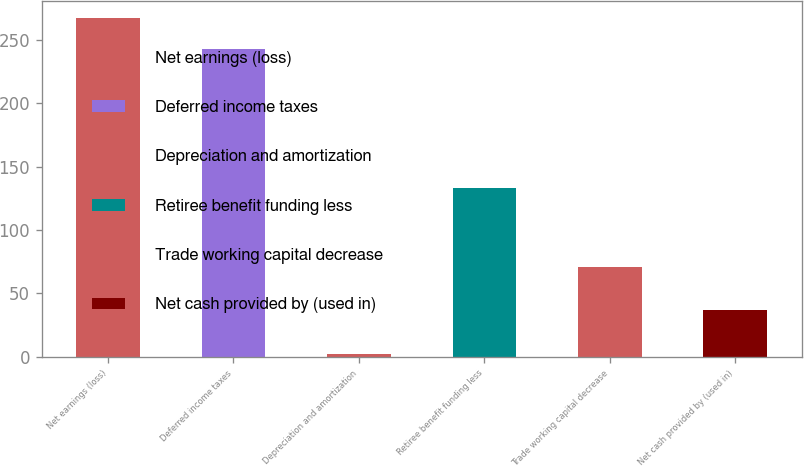Convert chart to OTSL. <chart><loc_0><loc_0><loc_500><loc_500><bar_chart><fcel>Net earnings (loss)<fcel>Deferred income taxes<fcel>Depreciation and amortization<fcel>Retiree benefit funding less<fcel>Trade working capital decrease<fcel>Net cash provided by (used in)<nl><fcel>267.4<fcel>243<fcel>2<fcel>133<fcel>71<fcel>37<nl></chart> 